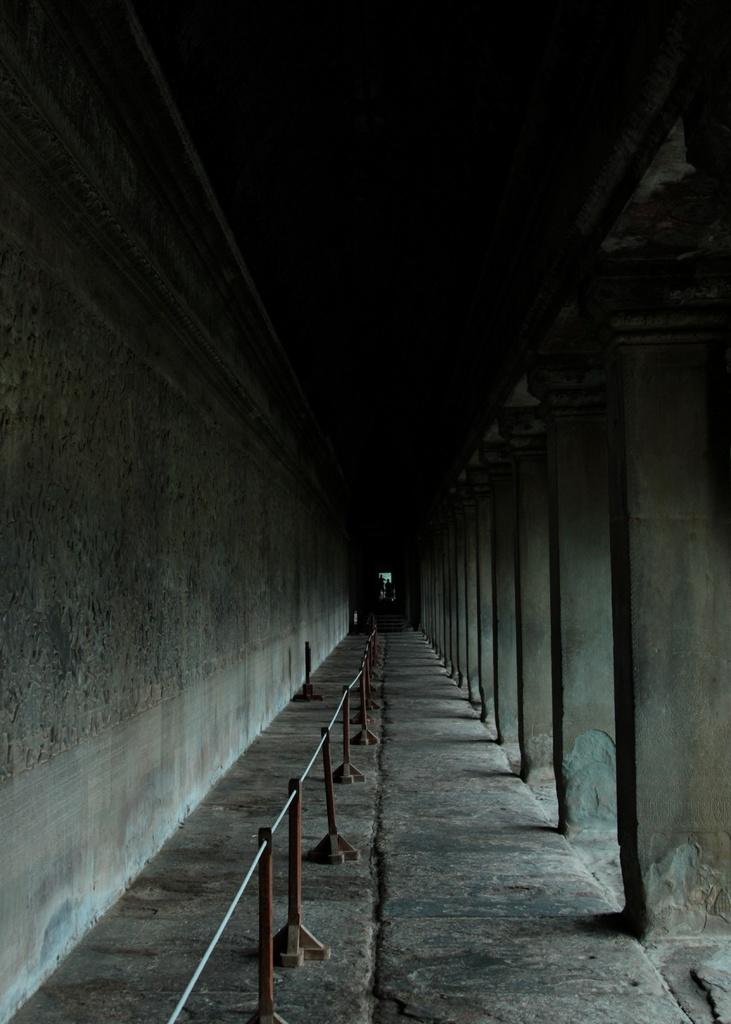What type of structure can be seen in the image? There is railing, a floor, pillars, and a wall visible in the image. Can you describe the railing in the image? The railing is a vertical barrier that provides support and safety. What is the purpose of the pillars in the image? The pillars provide support to the structure, helping to hold up the roof or ceiling. What is the wall made of in the image? The wall's material is not specified in the image, but it could be made of brick, concrete, or other materials. Can you see any clams crawling on the floor in the image? No, there are no clams present in the image. Is the water visible in the image? No, water is not visible in the image. 